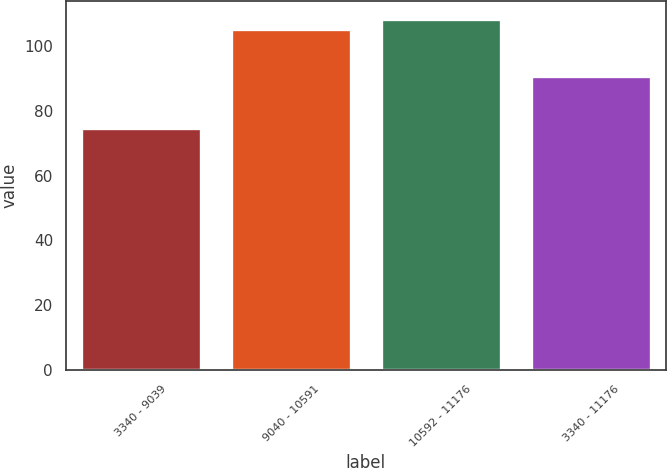Convert chart to OTSL. <chart><loc_0><loc_0><loc_500><loc_500><bar_chart><fcel>3340 - 9039<fcel>9040 - 10591<fcel>10592 - 11176<fcel>3340 - 11176<nl><fcel>74.72<fcel>105.12<fcel>108.3<fcel>90.77<nl></chart> 